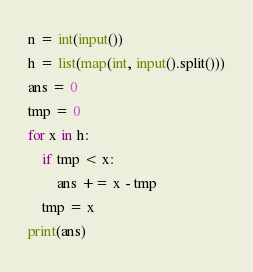<code> <loc_0><loc_0><loc_500><loc_500><_Python_>n = int(input())
h = list(map(int, input().split()))
ans = 0
tmp = 0
for x in h:
    if tmp < x:
        ans += x - tmp
    tmp = x
print(ans)</code> 